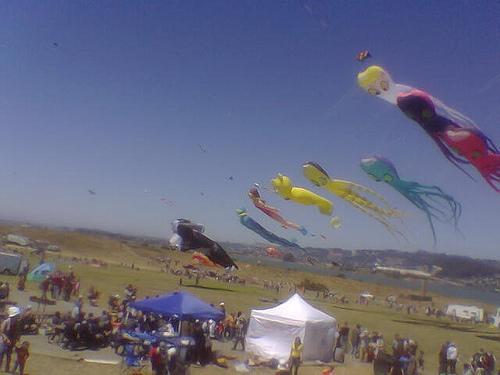Is that a competition?
Give a very brief answer. Yes. Have you ever seen objects like that flying in the sky?
Write a very short answer. No. How many tents are pictured?
Be succinct. 2. 